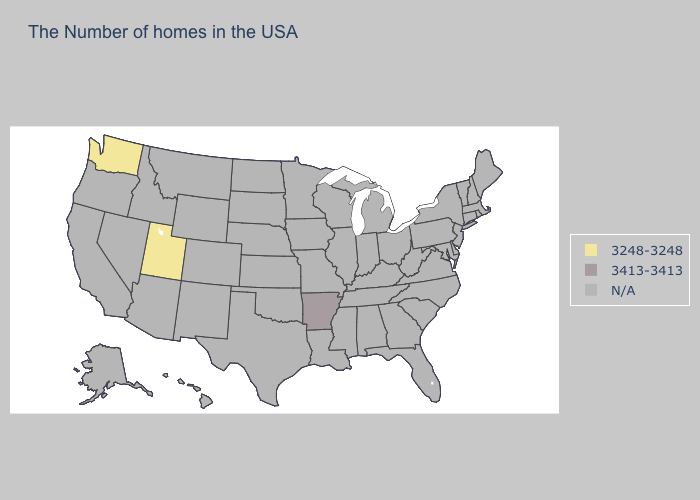Name the states that have a value in the range 3248-3248?
Keep it brief. Utah, Washington. Name the states that have a value in the range 3248-3248?
Give a very brief answer. Utah, Washington. What is the value of Oregon?
Write a very short answer. N/A. What is the lowest value in the USA?
Quick response, please. 3248-3248. Which states have the lowest value in the South?
Short answer required. Arkansas. Does the first symbol in the legend represent the smallest category?
Keep it brief. Yes. What is the value of Rhode Island?
Answer briefly. N/A. 